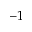<formula> <loc_0><loc_0><loc_500><loc_500>^ { - 1 }</formula> 